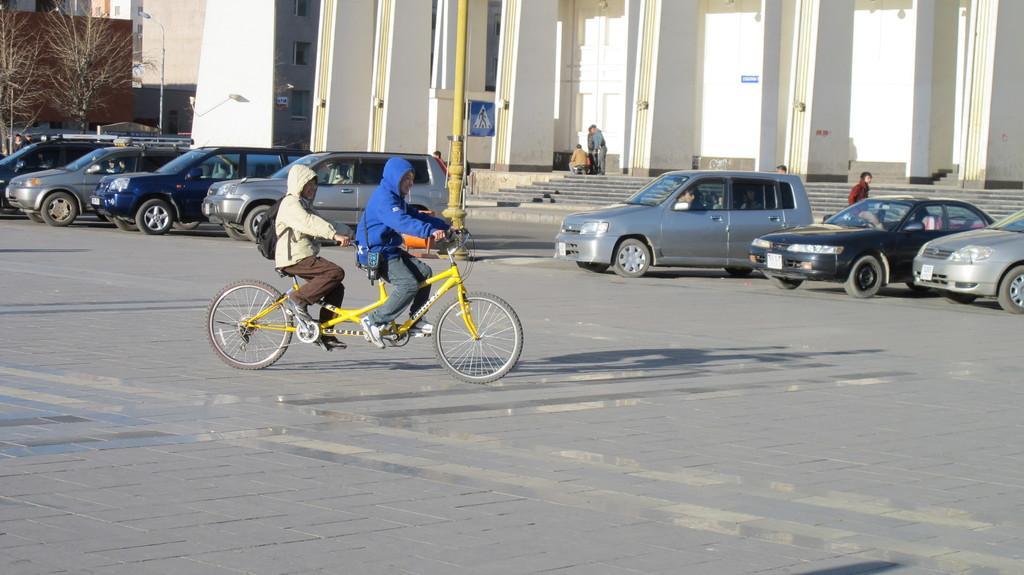Could you give a brief overview of what you see in this image? In the image we can see there are many vehicles and the people, they are wearing clothes and two of them are riding on a bicycle. Here we can see building, light pole, stairs, road and trees. 